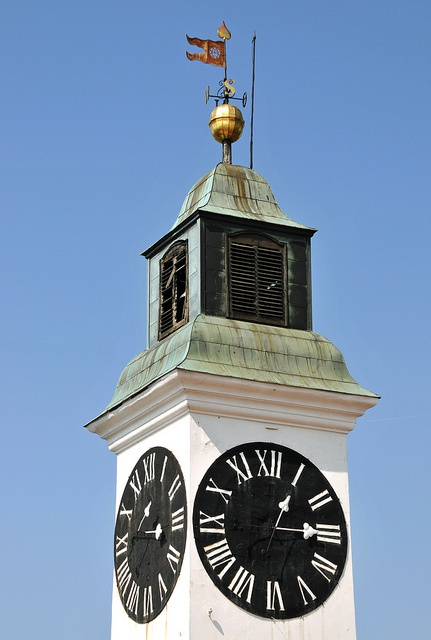Describe the objects in this image and their specific colors. I can see clock in gray, black, white, and darkgray tones and clock in gray, black, and white tones in this image. 